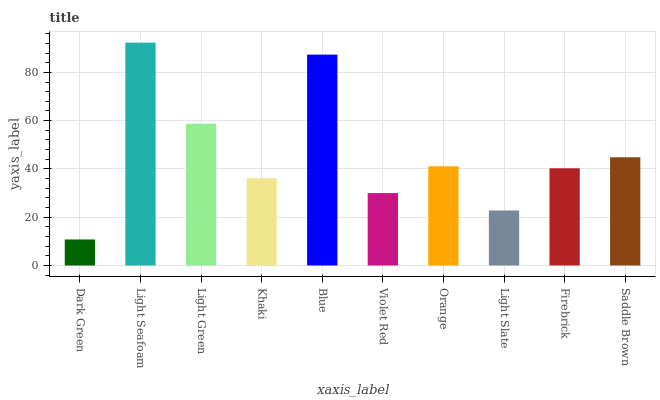Is Dark Green the minimum?
Answer yes or no. Yes. Is Light Seafoam the maximum?
Answer yes or no. Yes. Is Light Green the minimum?
Answer yes or no. No. Is Light Green the maximum?
Answer yes or no. No. Is Light Seafoam greater than Light Green?
Answer yes or no. Yes. Is Light Green less than Light Seafoam?
Answer yes or no. Yes. Is Light Green greater than Light Seafoam?
Answer yes or no. No. Is Light Seafoam less than Light Green?
Answer yes or no. No. Is Orange the high median?
Answer yes or no. Yes. Is Firebrick the low median?
Answer yes or no. Yes. Is Light Green the high median?
Answer yes or no. No. Is Violet Red the low median?
Answer yes or no. No. 